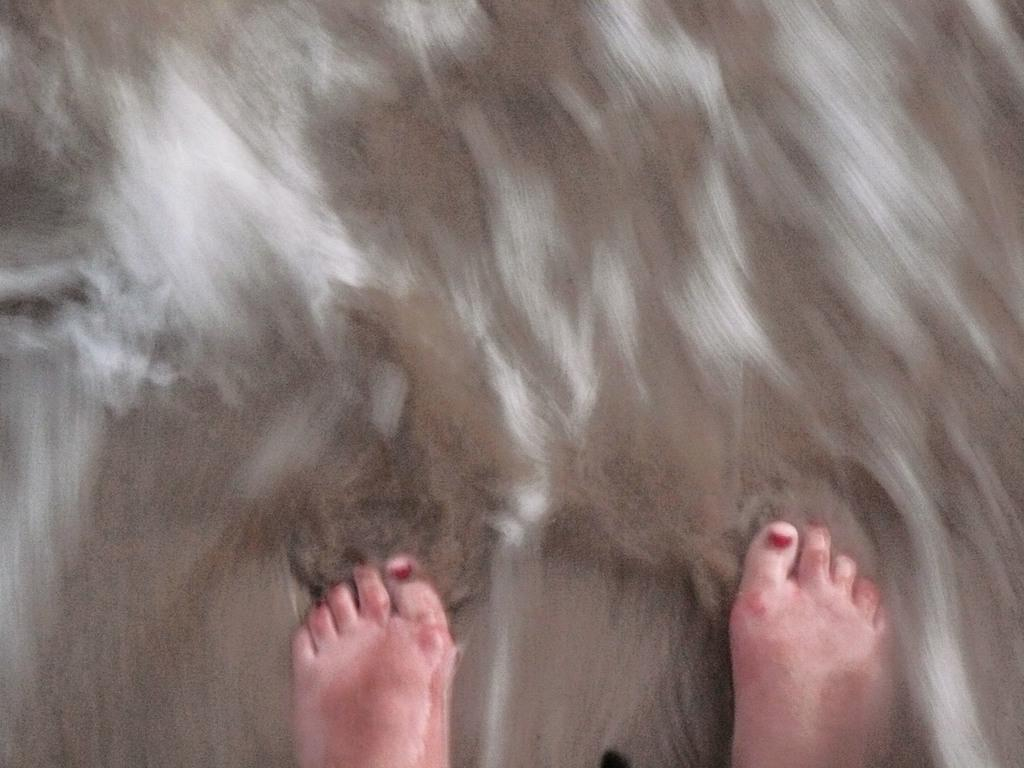What body part is visible in the image? There are legs visible in the image. Whose legs are visible in the image? The legs belong to a person. Where are the legs located in relation to the ground? The legs are on the ground. How would you describe the quality of the image? The image is blurry. What type of property is being fought over in the image? There is no fight or property present in the image; it only shows a person's legs on the ground. What color is the cub in the image? There is no cub present in the image. 